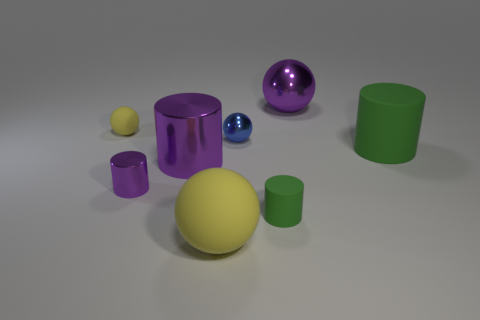How many other things are the same material as the blue object?
Your answer should be compact. 3. What is the purple object that is behind the small metal cylinder and in front of the large metal sphere made of?
Ensure brevity in your answer.  Metal. What number of large shiny objects are to the right of the blue object?
Give a very brief answer. 1. Are there any other things that are the same size as the blue ball?
Ensure brevity in your answer.  Yes. There is another ball that is the same material as the large yellow sphere; what color is it?
Offer a terse response. Yellow. Does the tiny purple metal thing have the same shape as the big yellow matte thing?
Offer a terse response. No. What number of purple shiny objects are in front of the blue metal ball and on the right side of the small purple cylinder?
Offer a terse response. 1. What number of metallic things are either small yellow balls or tiny blue cylinders?
Offer a very short reply. 0. What is the size of the rubber cylinder right of the green cylinder that is left of the large green cylinder?
Provide a short and direct response. Large. There is a large cylinder that is the same color as the tiny metallic cylinder; what is its material?
Ensure brevity in your answer.  Metal. 